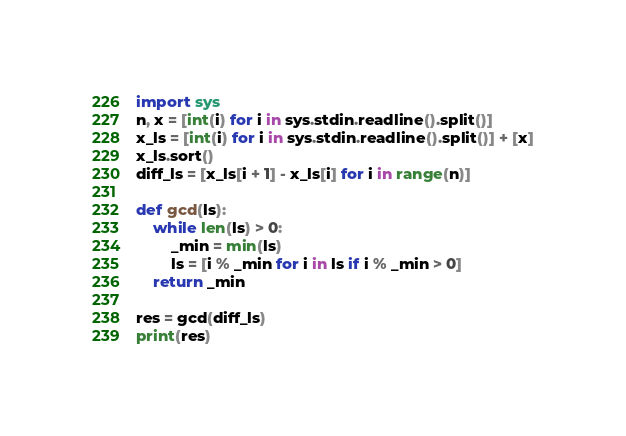Convert code to text. <code><loc_0><loc_0><loc_500><loc_500><_Python_>import sys
n, x = [int(i) for i in sys.stdin.readline().split()]
x_ls = [int(i) for i in sys.stdin.readline().split()] + [x]
x_ls.sort()
diff_ls = [x_ls[i + 1] - x_ls[i] for i in range(n)]

def gcd(ls):
    while len(ls) > 0:
        _min = min(ls)
        ls = [i % _min for i in ls if i % _min > 0]
    return _min

res = gcd(diff_ls)
print(res)</code> 